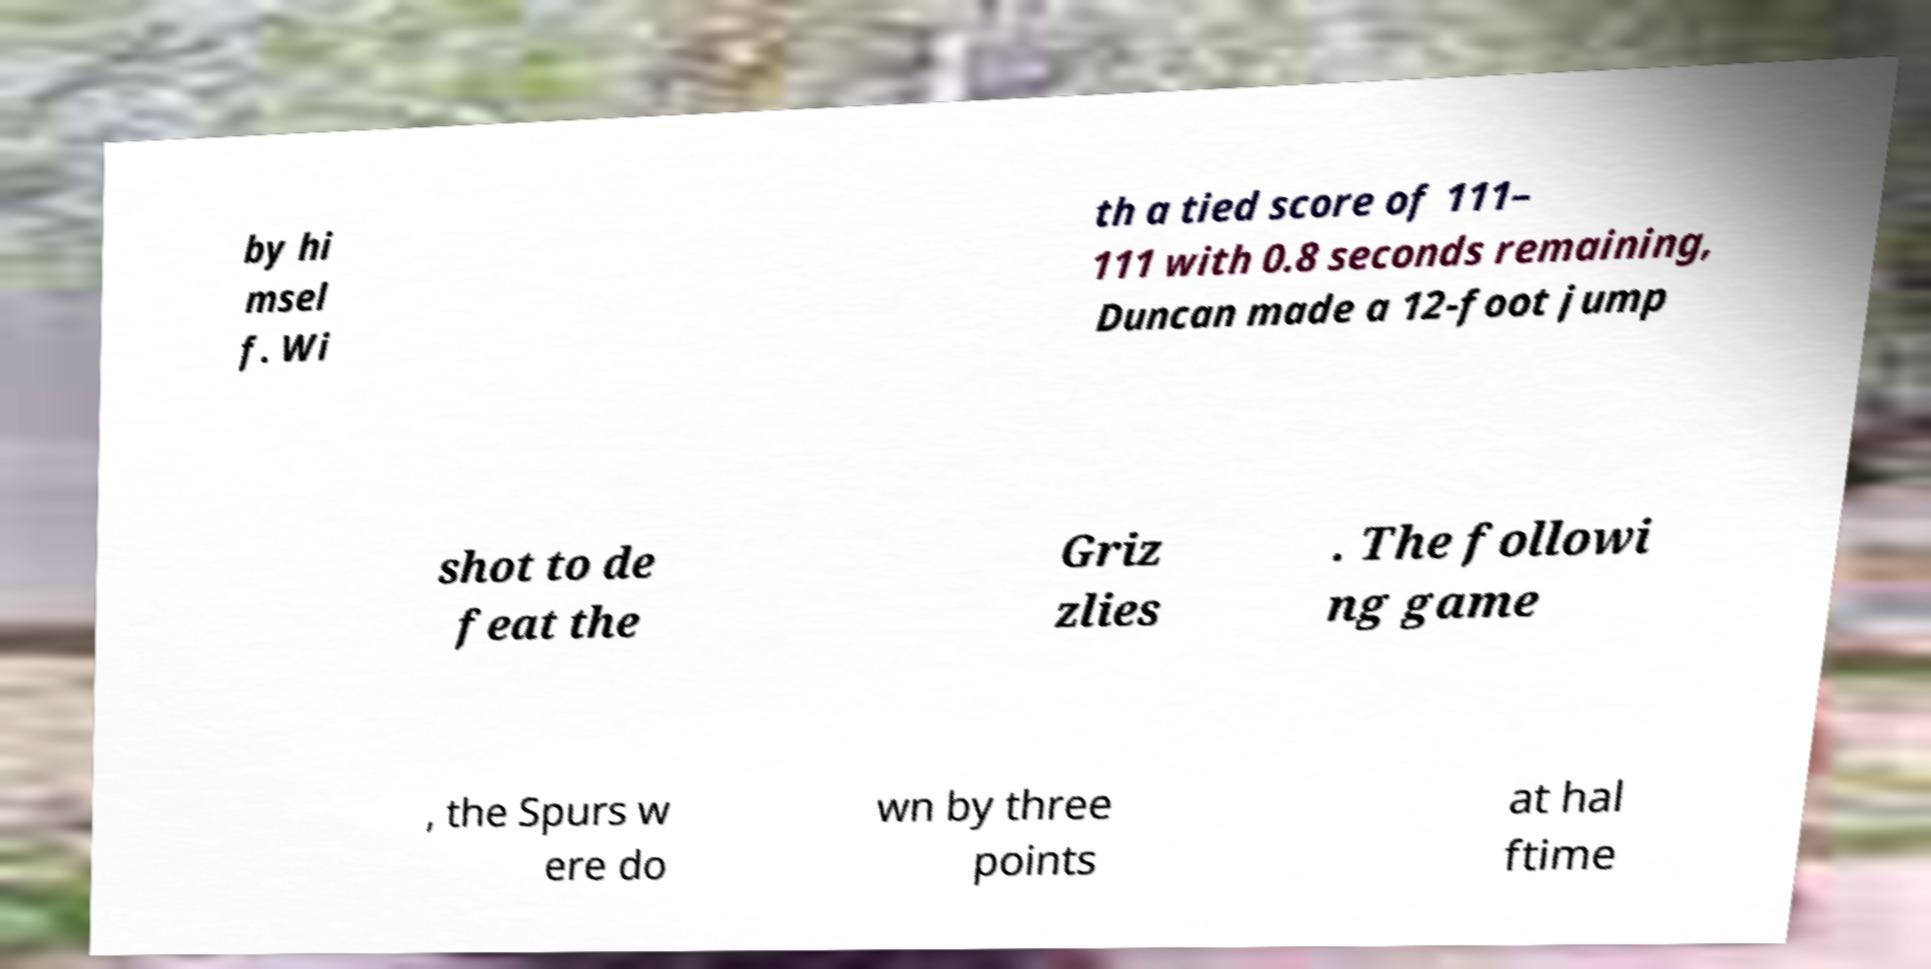For documentation purposes, I need the text within this image transcribed. Could you provide that? by hi msel f. Wi th a tied score of 111– 111 with 0.8 seconds remaining, Duncan made a 12-foot jump shot to de feat the Griz zlies . The followi ng game , the Spurs w ere do wn by three points at hal ftime 